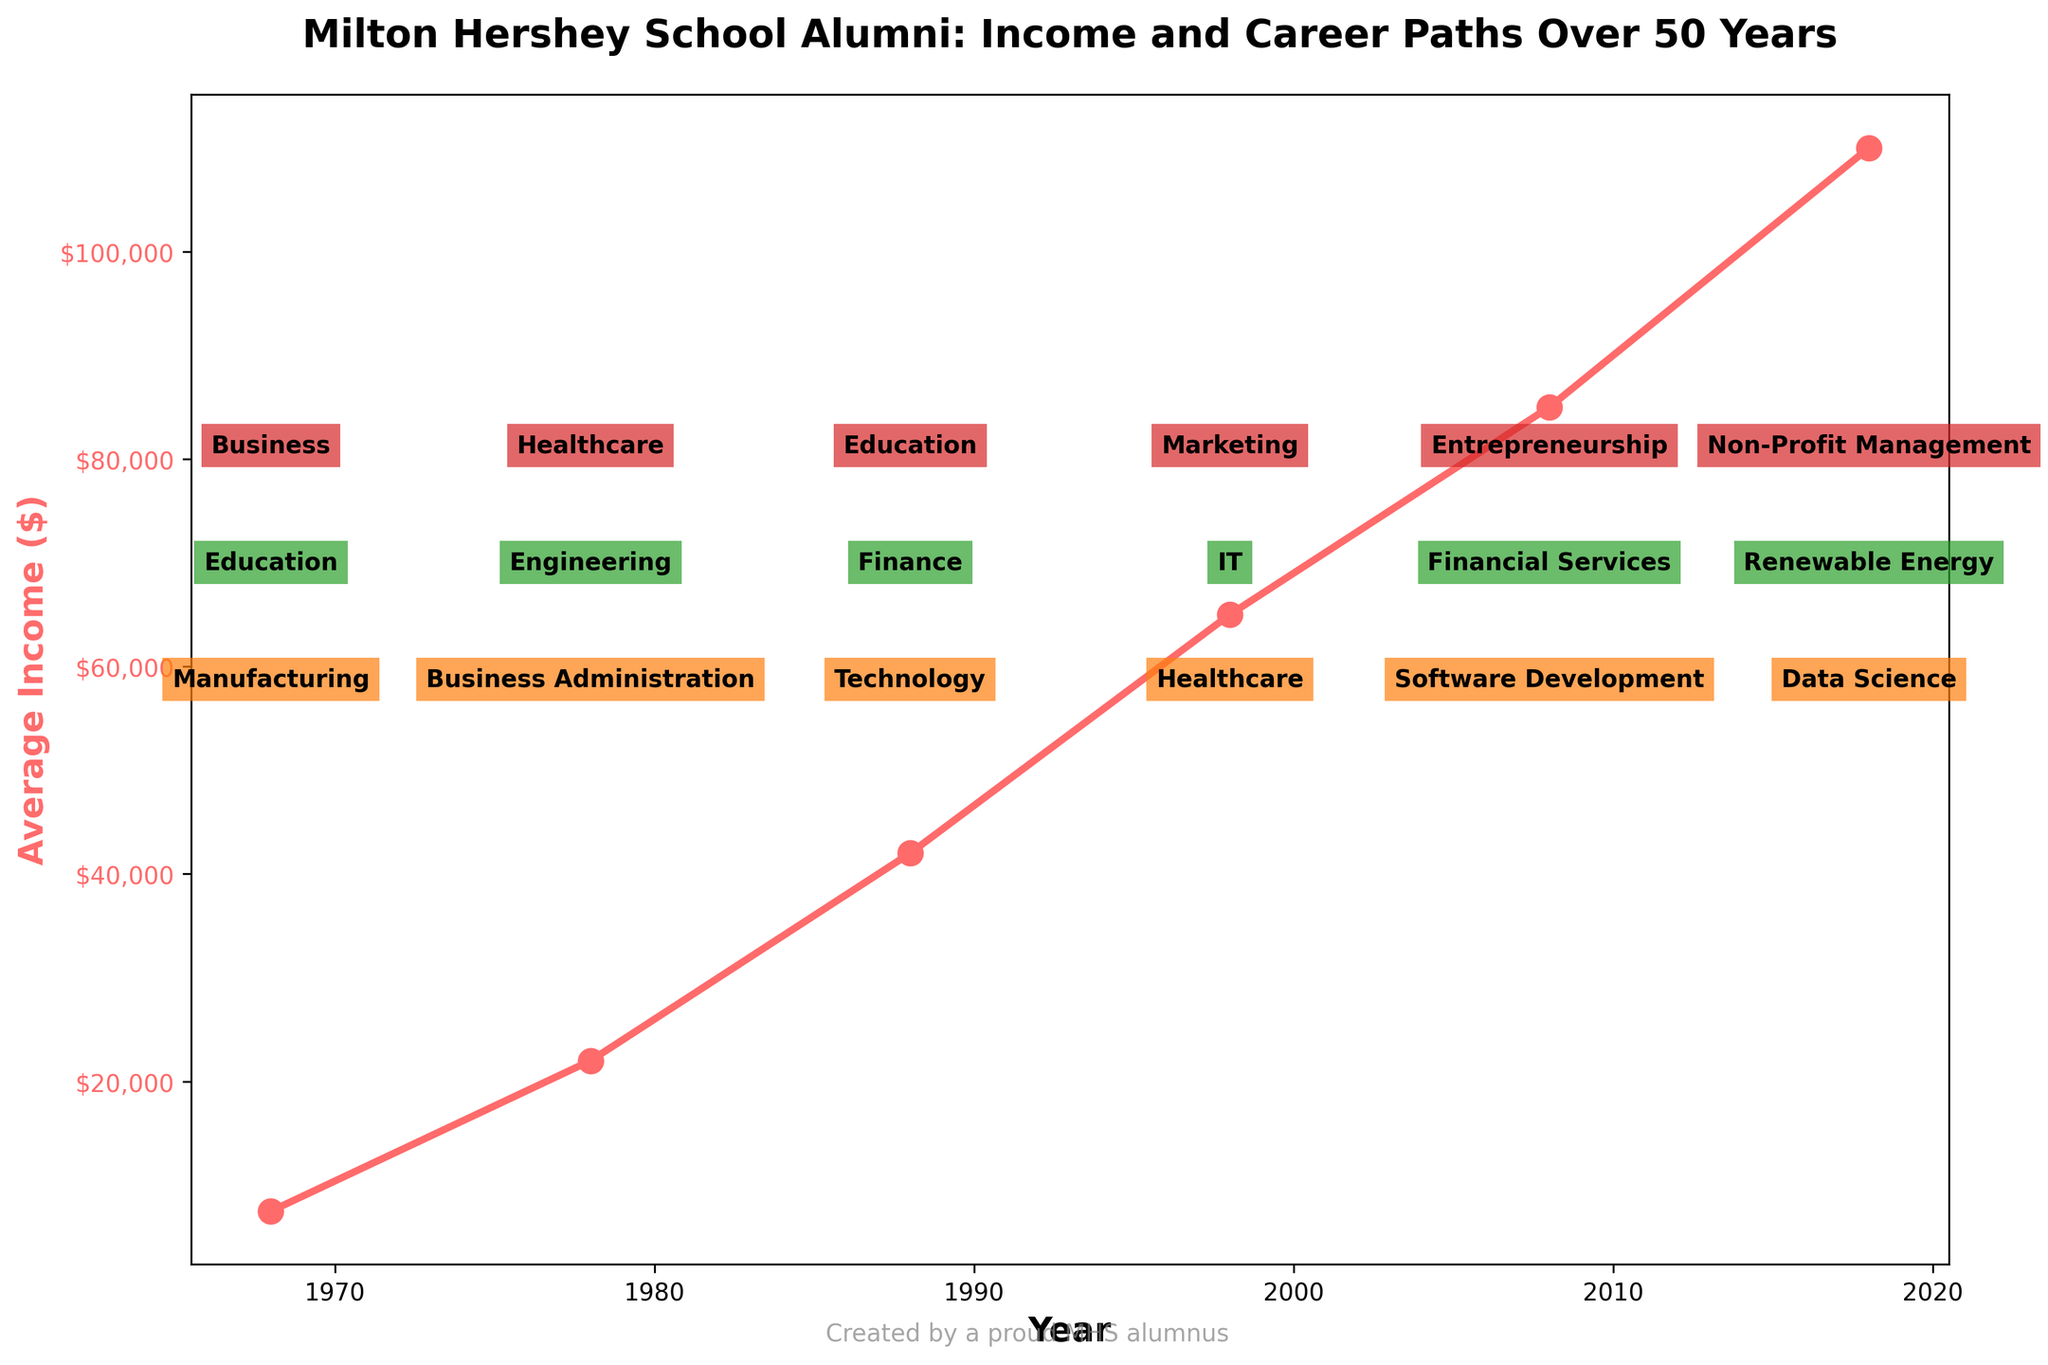What is the average increase in income per decade between 1968 and 2018? To find the average increase per decade, first calculate the total increase: $110,000 (2018) - $7,500 (1968) = $102,500. There are 5 decades between 1968 and 2018, so the average increase per decade is $102,500 / 5.
Answer: $20,500 Which year experienced the highest average income? Look at the plot and identify the year with the highest y-axis value for average income, which is the peak point in the plot. This year corresponds to 2018.
Answer: 2018 What are the top three career paths in 1988? Refer to the text annotations directly above the year 1988 on the plot to find the career paths listed: Technology, Finance, and Education.
Answer: Technology, Finance, Education Which period saw the greatest increase in average income, 1968-1978 or 1978-1988? Calculate the income increase for each period:
1968-1978: $22,000 - $7,500 = $14,500
1978-1988: $42,000 - $22,000 = $20,000
The period between 1978 and 1988 saw a greater increase.
Answer: 1978-1988 How many different career paths are indicated for the year 2008 on the plot? Identify the text annotations directly above the year 2008 on the plot and count the number of unique career paths listed: Software Development, Financial Services, and Entrepreneurship.
Answer: 3 In which year did the average income first surpass $50,000? Identify the year on the x-axis where the line representing average income first crosses above the $50,000 mark on the y-axis. This occurs in 1988.
Answer: 1988 What is the difference in average income between 1998 and 2018? Subtract the average income in 1998 from the average income in 2018: $110,000 - $65,000 = $45,000.
Answer: $45,000 Which career path appears most frequently as a top career path over the entire period? Scan the plot to note down each top career path from 1968 to 2018 and count the occurrences. Technology appears twice as a top career path (1988 and 2008).
Answer: Technology 